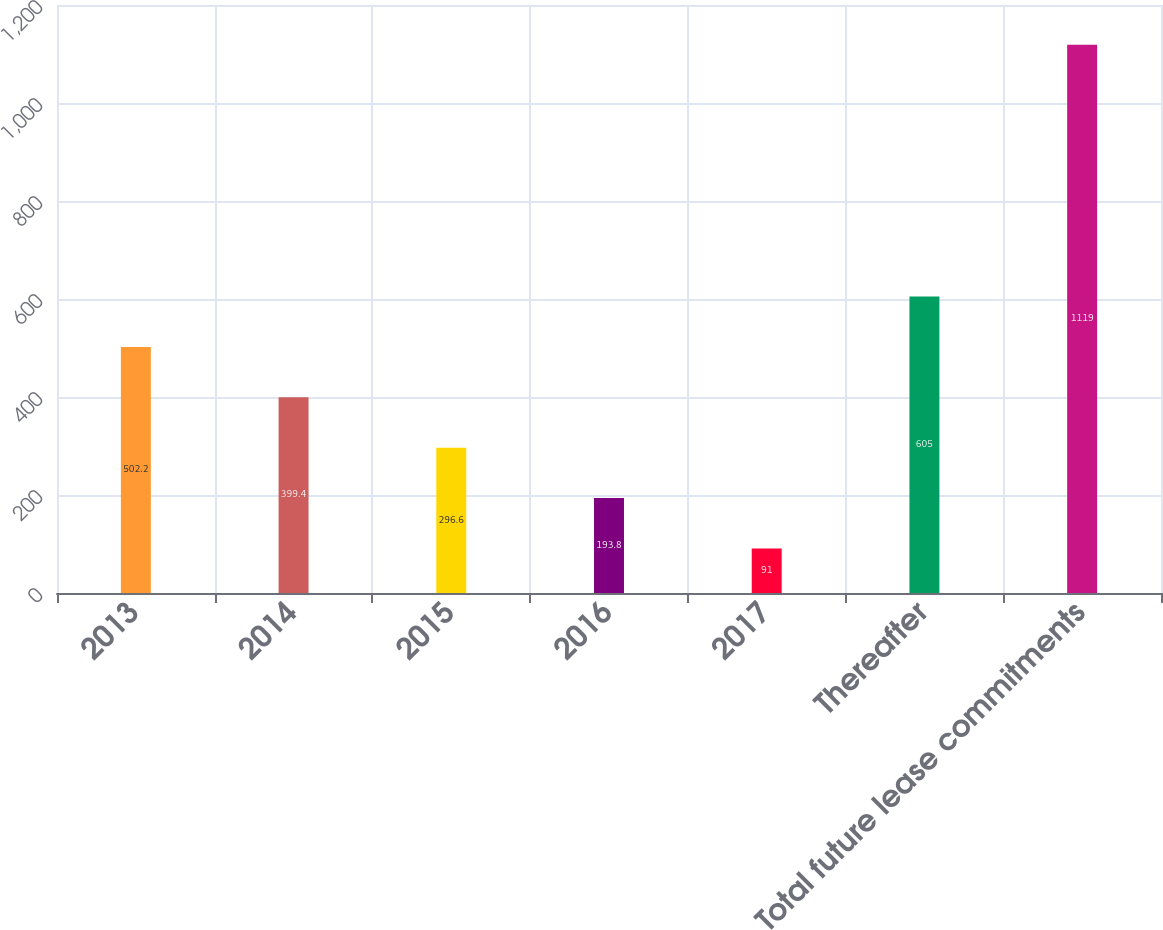<chart> <loc_0><loc_0><loc_500><loc_500><bar_chart><fcel>2013<fcel>2014<fcel>2015<fcel>2016<fcel>2017<fcel>Thereafter<fcel>Total future lease commitments<nl><fcel>502.2<fcel>399.4<fcel>296.6<fcel>193.8<fcel>91<fcel>605<fcel>1119<nl></chart> 